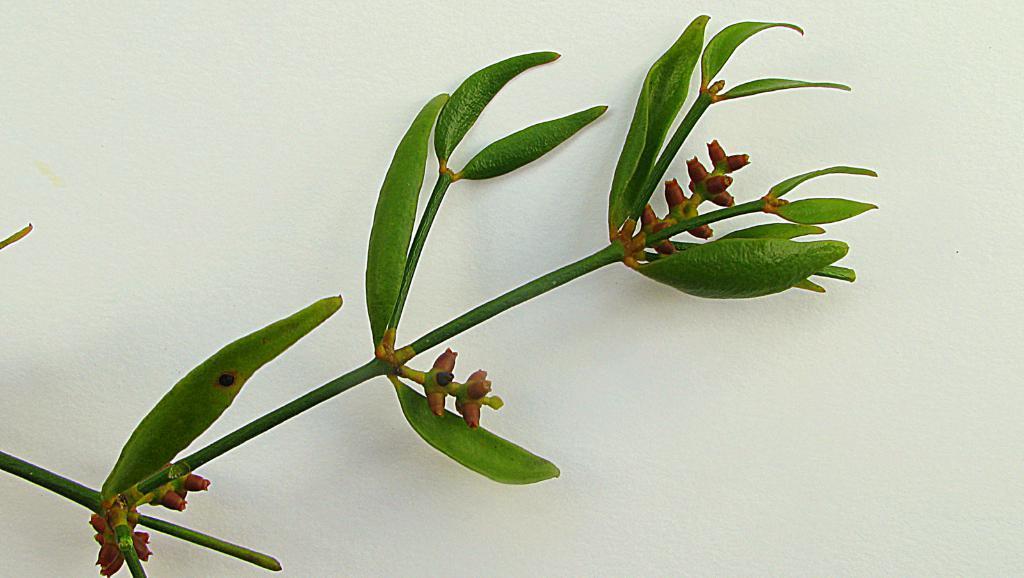Describe this image in one or two sentences. In the image we can see leaves, stem and white surface. 